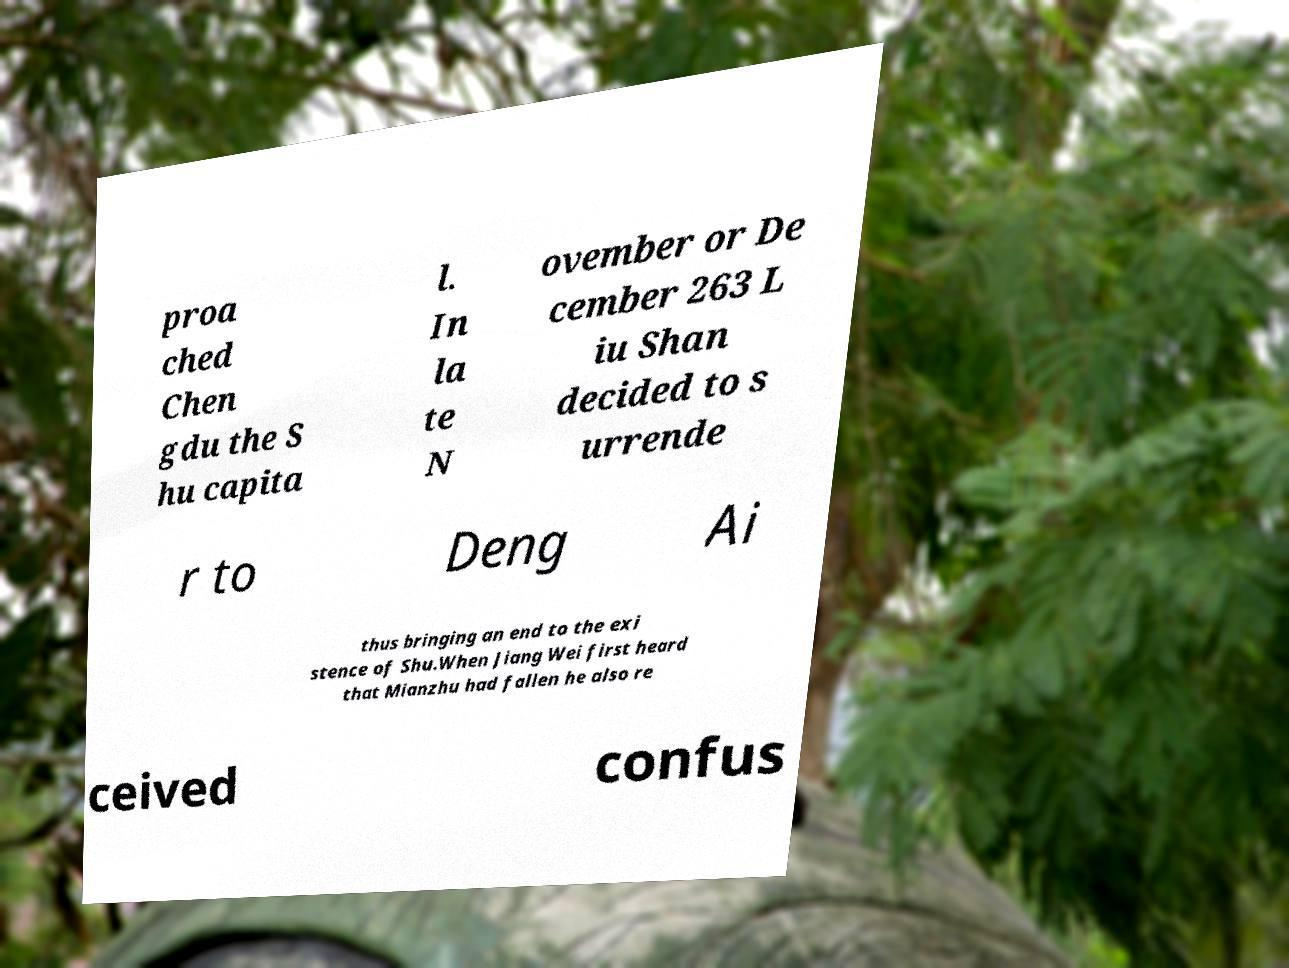Can you read and provide the text displayed in the image?This photo seems to have some interesting text. Can you extract and type it out for me? proa ched Chen gdu the S hu capita l. In la te N ovember or De cember 263 L iu Shan decided to s urrende r to Deng Ai thus bringing an end to the exi stence of Shu.When Jiang Wei first heard that Mianzhu had fallen he also re ceived confus 